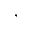<formula> <loc_0><loc_0><loc_500><loc_500>,</formula> 